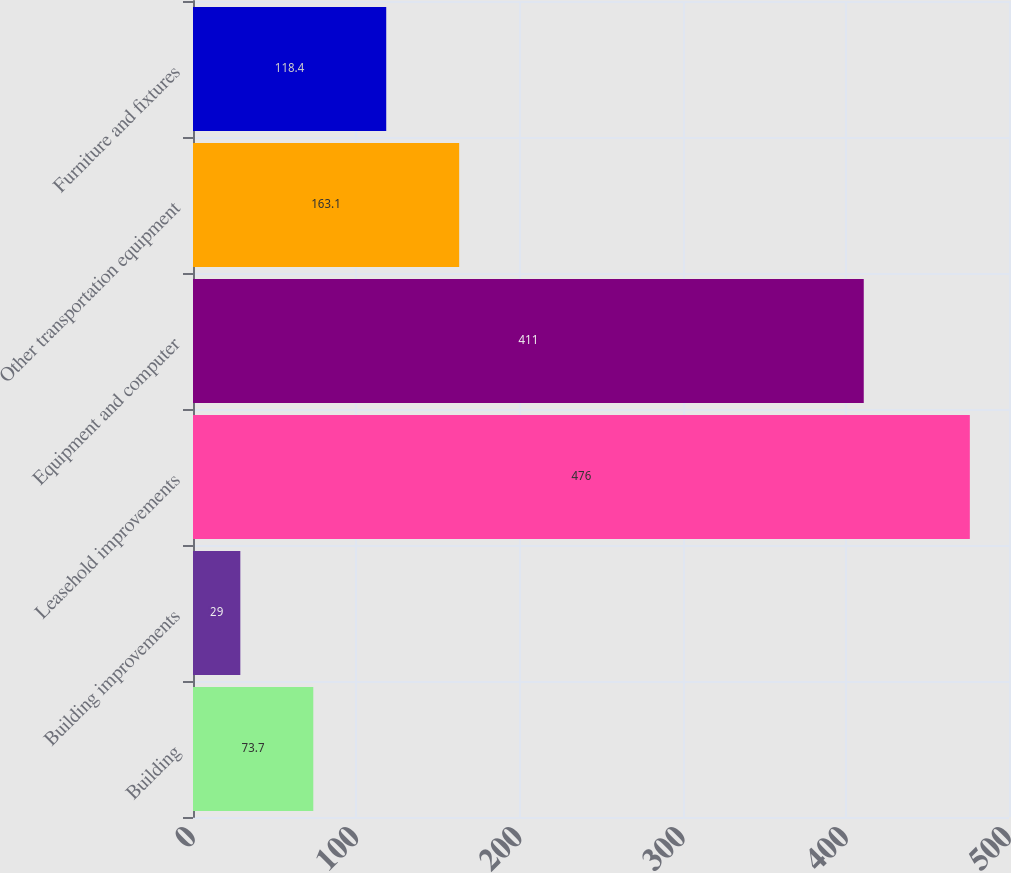<chart> <loc_0><loc_0><loc_500><loc_500><bar_chart><fcel>Building<fcel>Building improvements<fcel>Leasehold improvements<fcel>Equipment and computer<fcel>Other transportation equipment<fcel>Furniture and fixtures<nl><fcel>73.7<fcel>29<fcel>476<fcel>411<fcel>163.1<fcel>118.4<nl></chart> 